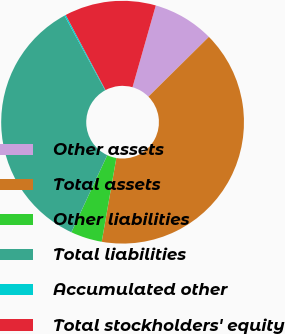<chart> <loc_0><loc_0><loc_500><loc_500><pie_chart><fcel>Other assets<fcel>Total assets<fcel>Other liabilities<fcel>Total liabilities<fcel>Accumulated other<fcel>Total stockholders' equity<nl><fcel>8.18%<fcel>40.16%<fcel>4.18%<fcel>35.13%<fcel>0.18%<fcel>12.17%<nl></chart> 